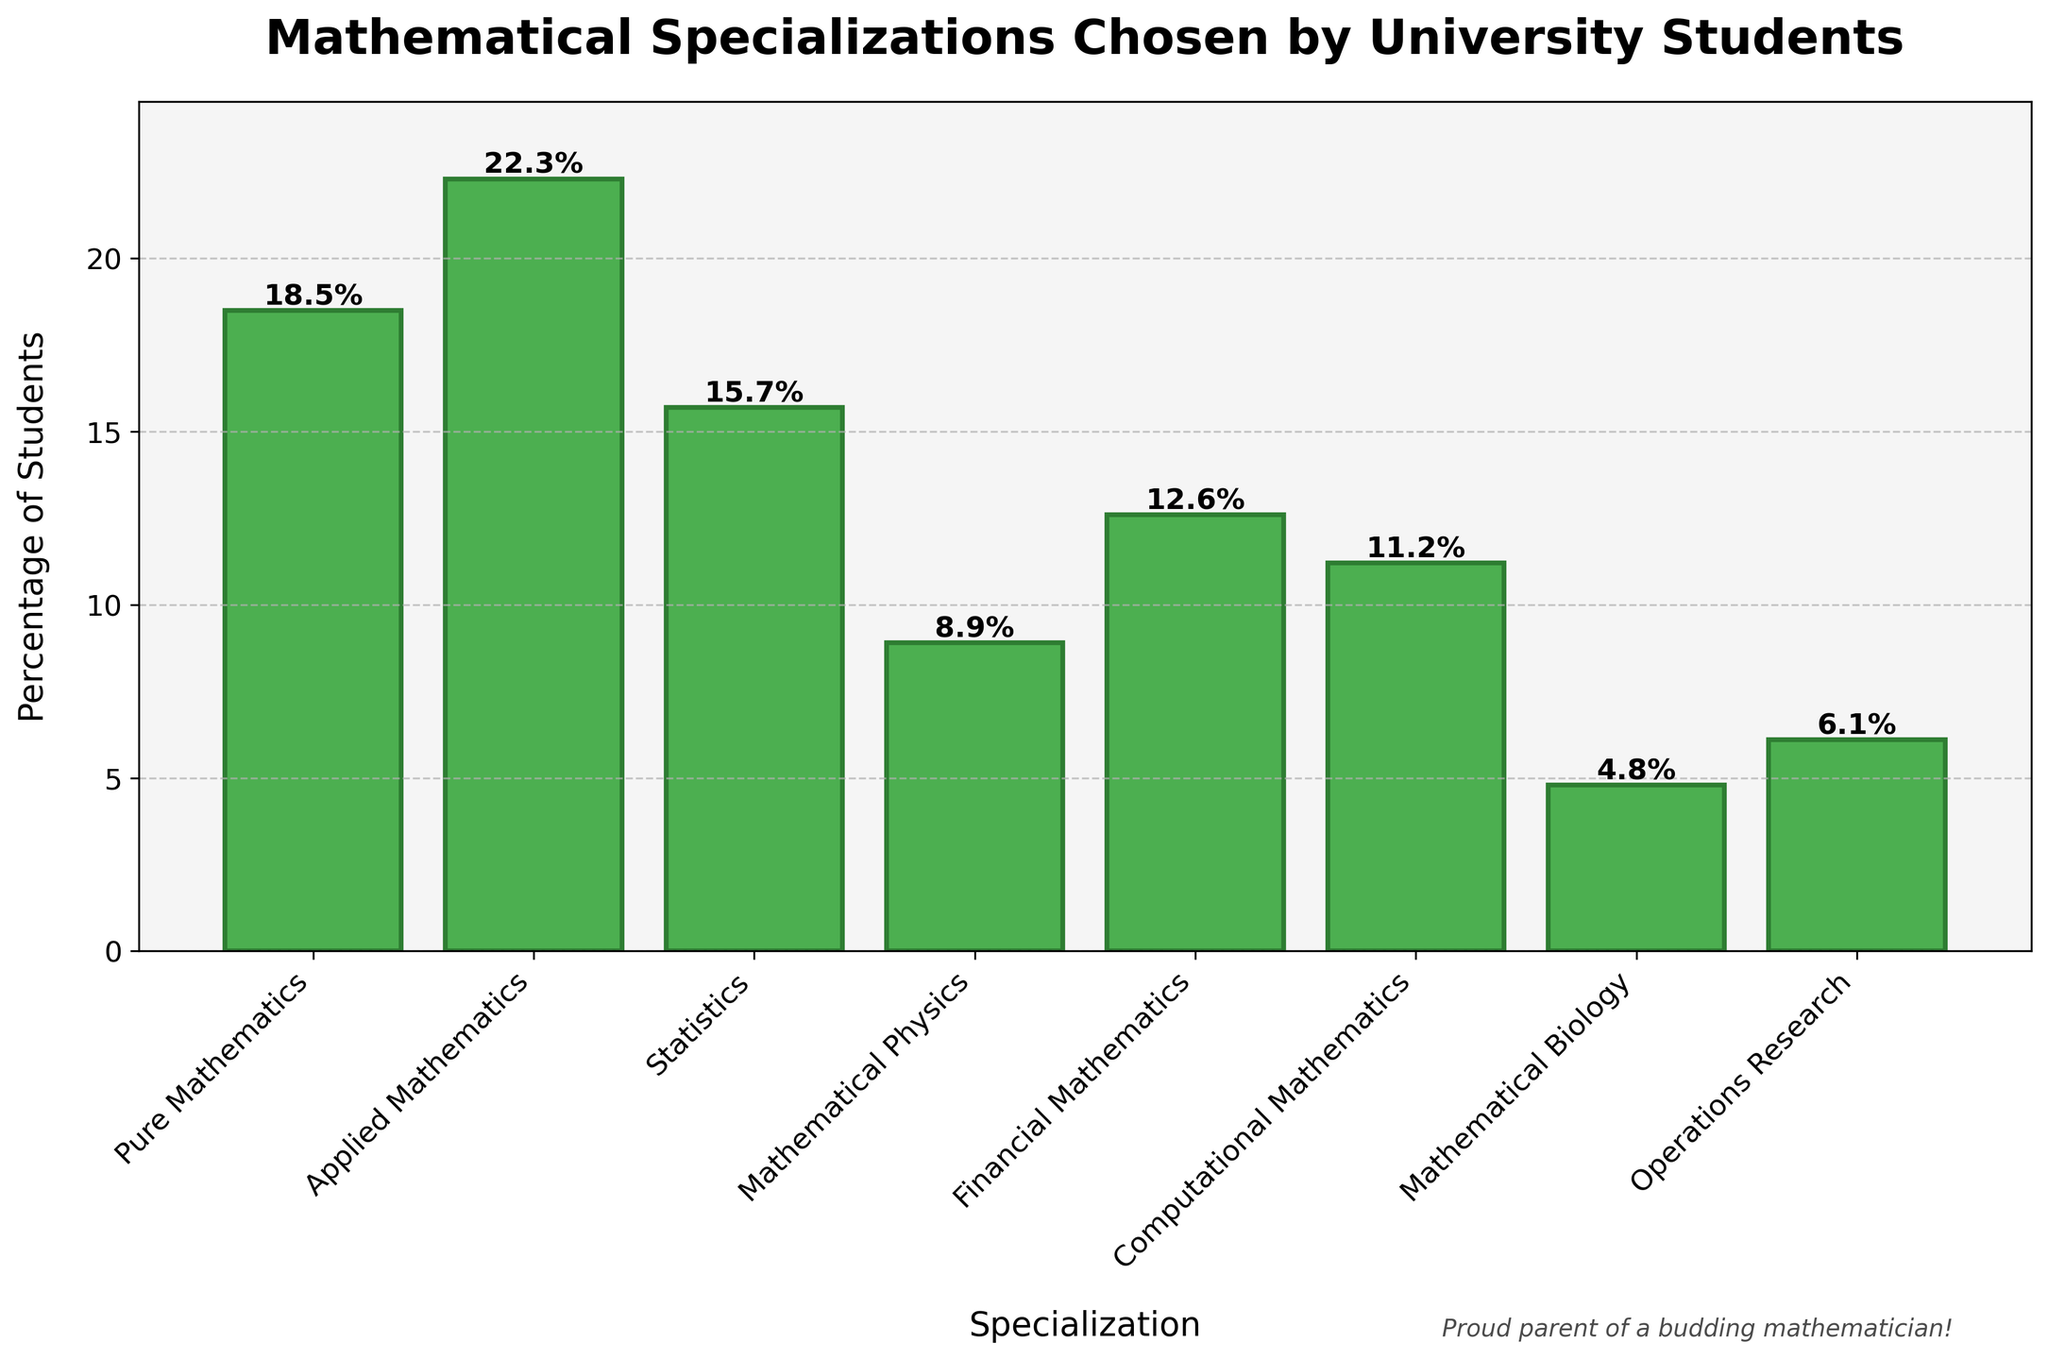What is the percentage of students choosing Applied Mathematics? The bar representing Applied Mathematics is labeled at 22.3%. This is a straightforward observation from the figure.
Answer: 22.3% Which specialization has the lowest percentage of students? By examining the heights of the bars, Mathematical Biology has the shortest bar, indicating it has the lowest percentage. The numerical value confirms this as 4.8%.
Answer: Mathematical Biology What is the difference in percentage between students choosing Applied Mathematics and Pure Mathematics? The percentage for Applied Mathematics is 22.3% and for Pure Mathematics is 18.5%. Subtracting these values: 22.3% - 18.5% = 3.8%.
Answer: 3.8% What is the combined percentage of students choosing Statistics and Financial Mathematics? The percentage for Statistics is 15.7% and for Financial Mathematics is 12.6%. Adding these values: 15.7% + 12.6% = 28.3%.
Answer: 28.3% Which specializations have percentages greater than 10%? By examining the figure, the specializations with bars above the 10% mark are Pure Mathematics (18.5%), Applied Mathematics (22.3%), Statistics (15.7%), and Financial Mathematics (12.6%).
Answer: Pure Mathematics, Applied Mathematics, Statistics, Financial Mathematics How many specializations have a percentage lower than 10%? Counting the bars: Mathematical Physics (8.9%), Computational Mathematics (11.2%, which is not lower than 10%), Mathematical Biology (4.8%), Operations Research (6.1%). Therefore, three specializations.
Answer: 3 Which specialization has the highest percentage of students? The bar for Applied Mathematics is the tallest, indicating the highest percentage at 22.3%.
Answer: Applied Mathematics What is the range of percentages across all specializations? The highest percentage is Applied Mathematics at 22.3%, and the lowest is Mathematical Biology at 4.8%. The range is 22.3% - 4.8% = 17.5%.
Answer: 17.5% What is the average percentage of students per specialization? Sum the percentages: 18.5% + 22.3% + 15.7% + 8.9% + 12.6% + 11.2% + 4.8% + 6.1% = 100.1%. There are 8 specializations. The average is 100.1% / 8 ≈ 12.5%.
Answer: 12.5% If 1000 students are surveyed, how many chose Computational Mathematics? The percentage for Computational Mathematics is 11.2%. Therefore, 11.2% of 1000 students is 0.112 * 1000 = 112 students.
Answer: 112 